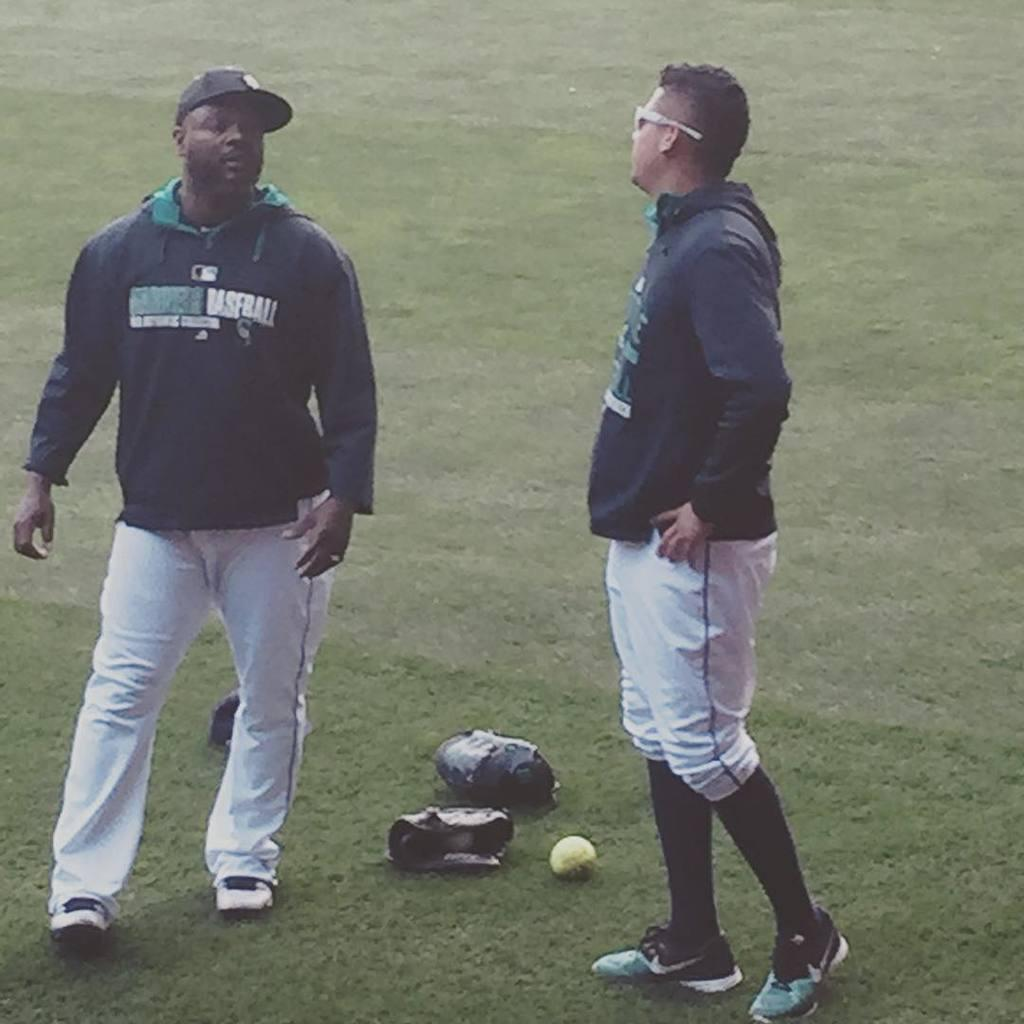<image>
Share a concise interpretation of the image provided. Two men are on the grass, one shirt has the word baseball. 